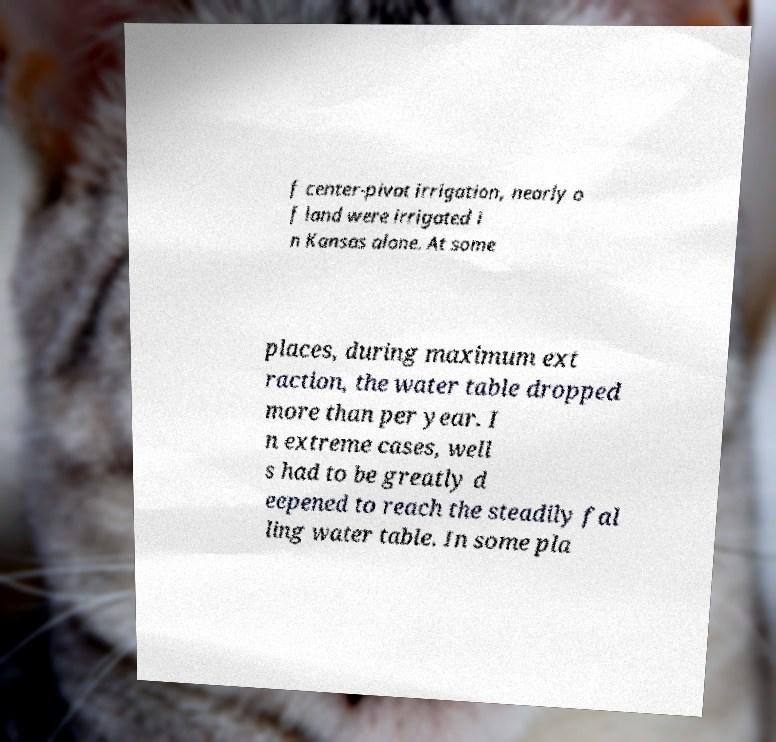I need the written content from this picture converted into text. Can you do that? f center-pivot irrigation, nearly o f land were irrigated i n Kansas alone. At some places, during maximum ext raction, the water table dropped more than per year. I n extreme cases, well s had to be greatly d eepened to reach the steadily fal ling water table. In some pla 